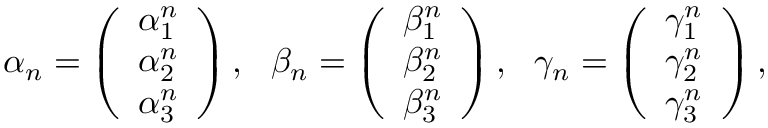<formula> <loc_0><loc_0><loc_500><loc_500>\alpha _ { n } = \left ( \begin{array} { l } { \alpha _ { 1 } ^ { n } } \\ { \alpha _ { 2 } ^ { n } } \\ { \alpha _ { 3 } ^ { n } } \end{array} \right ) , \quad b e t a _ { n } = \left ( \begin{array} { l } { \beta _ { 1 } ^ { n } } \\ { \beta _ { 2 } ^ { n } } \\ { \beta _ { 3 } ^ { n } } \end{array} \right ) , \quad g a m m a _ { n } = \left ( \begin{array} { l } { \gamma _ { 1 } ^ { n } } \\ { \gamma _ { 2 } ^ { n } } \\ { \gamma _ { 3 } ^ { n } } \end{array} \right ) ,</formula> 